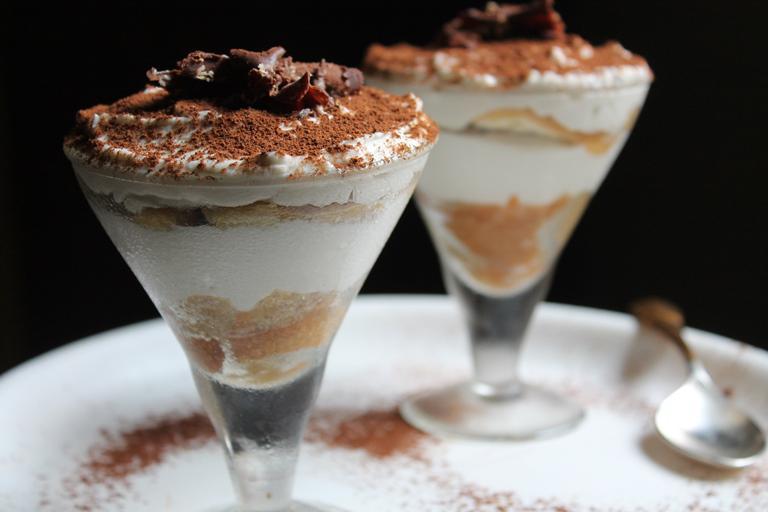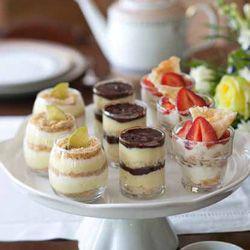The first image is the image on the left, the second image is the image on the right. For the images displayed, is the sentence "One of the images shows exactly one dessert container." factually correct? Answer yes or no. No. The first image is the image on the left, the second image is the image on the right. Examine the images to the left and right. Is the description "The left photo contains two cups full of dessert." accurate? Answer yes or no. Yes. 